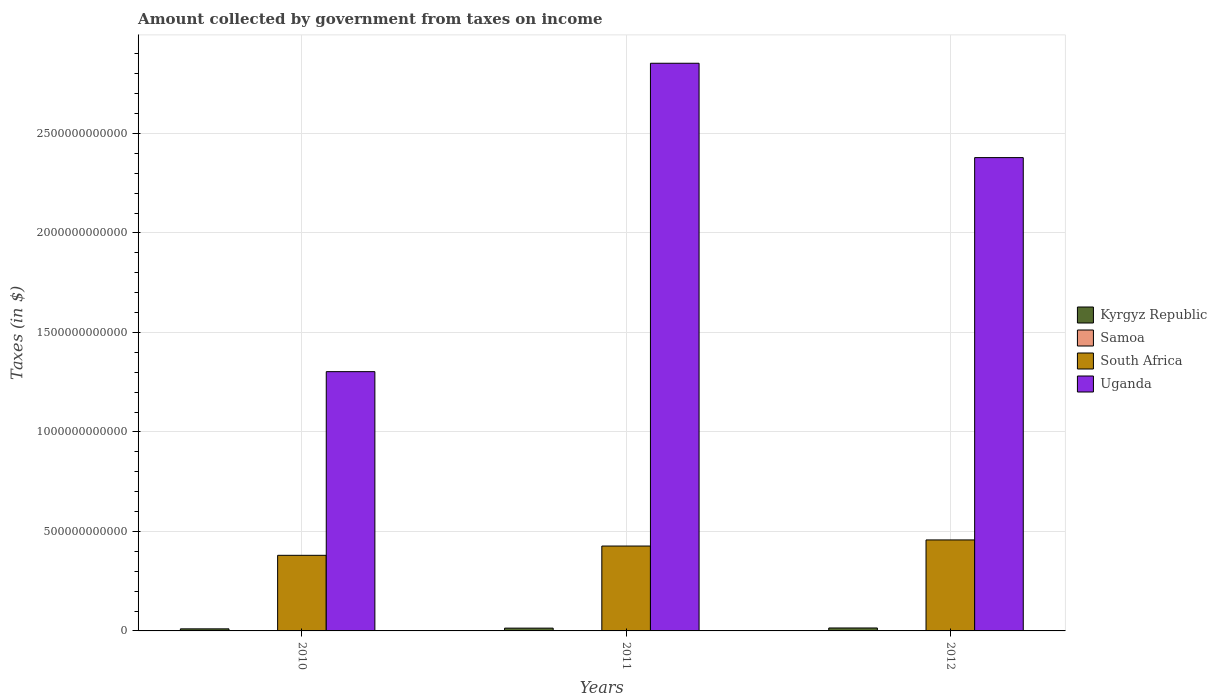Are the number of bars per tick equal to the number of legend labels?
Provide a short and direct response. Yes. How many bars are there on the 1st tick from the left?
Offer a very short reply. 4. What is the amount collected by government from taxes on income in South Africa in 2012?
Keep it short and to the point. 4.57e+11. Across all years, what is the maximum amount collected by government from taxes on income in South Africa?
Make the answer very short. 4.57e+11. Across all years, what is the minimum amount collected by government from taxes on income in South Africa?
Your answer should be very brief. 3.80e+11. In which year was the amount collected by government from taxes on income in Uganda maximum?
Offer a terse response. 2011. What is the total amount collected by government from taxes on income in Samoa in the graph?
Your response must be concise. 2.54e+05. What is the difference between the amount collected by government from taxes on income in Uganda in 2010 and that in 2011?
Make the answer very short. -1.55e+12. What is the difference between the amount collected by government from taxes on income in Uganda in 2011 and the amount collected by government from taxes on income in South Africa in 2012?
Make the answer very short. 2.40e+12. What is the average amount collected by government from taxes on income in Kyrgyz Republic per year?
Provide a short and direct response. 1.31e+1. In the year 2012, what is the difference between the amount collected by government from taxes on income in Samoa and amount collected by government from taxes on income in South Africa?
Keep it short and to the point. -4.57e+11. What is the ratio of the amount collected by government from taxes on income in South Africa in 2010 to that in 2012?
Provide a succinct answer. 0.83. Is the amount collected by government from taxes on income in Kyrgyz Republic in 2011 less than that in 2012?
Your response must be concise. Yes. Is the difference between the amount collected by government from taxes on income in Samoa in 2010 and 2011 greater than the difference between the amount collected by government from taxes on income in South Africa in 2010 and 2011?
Make the answer very short. Yes. What is the difference between the highest and the second highest amount collected by government from taxes on income in Samoa?
Your answer should be very brief. 7012.45. What is the difference between the highest and the lowest amount collected by government from taxes on income in Samoa?
Your answer should be very brief. 1.29e+04. Is the sum of the amount collected by government from taxes on income in Samoa in 2010 and 2011 greater than the maximum amount collected by government from taxes on income in Uganda across all years?
Offer a terse response. No. Is it the case that in every year, the sum of the amount collected by government from taxes on income in South Africa and amount collected by government from taxes on income in Uganda is greater than the sum of amount collected by government from taxes on income in Kyrgyz Republic and amount collected by government from taxes on income in Samoa?
Ensure brevity in your answer.  Yes. What does the 2nd bar from the left in 2011 represents?
Give a very brief answer. Samoa. What does the 2nd bar from the right in 2012 represents?
Offer a very short reply. South Africa. Is it the case that in every year, the sum of the amount collected by government from taxes on income in Uganda and amount collected by government from taxes on income in Kyrgyz Republic is greater than the amount collected by government from taxes on income in South Africa?
Your answer should be compact. Yes. How many bars are there?
Your response must be concise. 12. Are all the bars in the graph horizontal?
Ensure brevity in your answer.  No. What is the difference between two consecutive major ticks on the Y-axis?
Offer a very short reply. 5.00e+11. Are the values on the major ticks of Y-axis written in scientific E-notation?
Offer a terse response. No. Does the graph contain any zero values?
Offer a terse response. No. Where does the legend appear in the graph?
Provide a succinct answer. Center right. How many legend labels are there?
Ensure brevity in your answer.  4. What is the title of the graph?
Offer a very short reply. Amount collected by government from taxes on income. Does "Colombia" appear as one of the legend labels in the graph?
Give a very brief answer. No. What is the label or title of the Y-axis?
Ensure brevity in your answer.  Taxes (in $). What is the Taxes (in $) in Kyrgyz Republic in 2010?
Your response must be concise. 1.04e+1. What is the Taxes (in $) of Samoa in 2010?
Offer a very short reply. 7.85e+04. What is the Taxes (in $) of South Africa in 2010?
Provide a short and direct response. 3.80e+11. What is the Taxes (in $) of Uganda in 2010?
Your response must be concise. 1.30e+12. What is the Taxes (in $) in Kyrgyz Republic in 2011?
Provide a short and direct response. 1.40e+1. What is the Taxes (in $) in Samoa in 2011?
Your response must be concise. 8.44e+04. What is the Taxes (in $) of South Africa in 2011?
Offer a terse response. 4.27e+11. What is the Taxes (in $) of Uganda in 2011?
Your answer should be compact. 2.85e+12. What is the Taxes (in $) of Kyrgyz Republic in 2012?
Your response must be concise. 1.48e+1. What is the Taxes (in $) in Samoa in 2012?
Provide a succinct answer. 9.14e+04. What is the Taxes (in $) in South Africa in 2012?
Offer a very short reply. 4.57e+11. What is the Taxes (in $) in Uganda in 2012?
Your answer should be very brief. 2.38e+12. Across all years, what is the maximum Taxes (in $) in Kyrgyz Republic?
Offer a terse response. 1.48e+1. Across all years, what is the maximum Taxes (in $) of Samoa?
Keep it short and to the point. 9.14e+04. Across all years, what is the maximum Taxes (in $) in South Africa?
Offer a very short reply. 4.57e+11. Across all years, what is the maximum Taxes (in $) in Uganda?
Your answer should be compact. 2.85e+12. Across all years, what is the minimum Taxes (in $) of Kyrgyz Republic?
Offer a very short reply. 1.04e+1. Across all years, what is the minimum Taxes (in $) in Samoa?
Give a very brief answer. 7.85e+04. Across all years, what is the minimum Taxes (in $) in South Africa?
Your answer should be very brief. 3.80e+11. Across all years, what is the minimum Taxes (in $) of Uganda?
Ensure brevity in your answer.  1.30e+12. What is the total Taxes (in $) of Kyrgyz Republic in the graph?
Your answer should be very brief. 3.92e+1. What is the total Taxes (in $) of Samoa in the graph?
Offer a very short reply. 2.54e+05. What is the total Taxes (in $) in South Africa in the graph?
Keep it short and to the point. 1.26e+12. What is the total Taxes (in $) of Uganda in the graph?
Your answer should be compact. 6.53e+12. What is the difference between the Taxes (in $) of Kyrgyz Republic in 2010 and that in 2011?
Ensure brevity in your answer.  -3.59e+09. What is the difference between the Taxes (in $) in Samoa in 2010 and that in 2011?
Ensure brevity in your answer.  -5846.93. What is the difference between the Taxes (in $) in South Africa in 2010 and that in 2011?
Your answer should be very brief. -4.66e+1. What is the difference between the Taxes (in $) in Uganda in 2010 and that in 2011?
Make the answer very short. -1.55e+12. What is the difference between the Taxes (in $) of Kyrgyz Republic in 2010 and that in 2012?
Your response must be concise. -4.42e+09. What is the difference between the Taxes (in $) in Samoa in 2010 and that in 2012?
Your answer should be very brief. -1.29e+04. What is the difference between the Taxes (in $) of South Africa in 2010 and that in 2012?
Make the answer very short. -7.74e+1. What is the difference between the Taxes (in $) of Uganda in 2010 and that in 2012?
Keep it short and to the point. -1.08e+12. What is the difference between the Taxes (in $) of Kyrgyz Republic in 2011 and that in 2012?
Provide a succinct answer. -8.29e+08. What is the difference between the Taxes (in $) of Samoa in 2011 and that in 2012?
Give a very brief answer. -7012.45. What is the difference between the Taxes (in $) in South Africa in 2011 and that in 2012?
Your response must be concise. -3.07e+1. What is the difference between the Taxes (in $) of Uganda in 2011 and that in 2012?
Keep it short and to the point. 4.74e+11. What is the difference between the Taxes (in $) in Kyrgyz Republic in 2010 and the Taxes (in $) in Samoa in 2011?
Offer a terse response. 1.04e+1. What is the difference between the Taxes (in $) of Kyrgyz Republic in 2010 and the Taxes (in $) of South Africa in 2011?
Keep it short and to the point. -4.16e+11. What is the difference between the Taxes (in $) in Kyrgyz Republic in 2010 and the Taxes (in $) in Uganda in 2011?
Your response must be concise. -2.84e+12. What is the difference between the Taxes (in $) in Samoa in 2010 and the Taxes (in $) in South Africa in 2011?
Your answer should be compact. -4.27e+11. What is the difference between the Taxes (in $) of Samoa in 2010 and the Taxes (in $) of Uganda in 2011?
Provide a succinct answer. -2.85e+12. What is the difference between the Taxes (in $) of South Africa in 2010 and the Taxes (in $) of Uganda in 2011?
Offer a terse response. -2.47e+12. What is the difference between the Taxes (in $) of Kyrgyz Republic in 2010 and the Taxes (in $) of Samoa in 2012?
Your answer should be very brief. 1.04e+1. What is the difference between the Taxes (in $) of Kyrgyz Republic in 2010 and the Taxes (in $) of South Africa in 2012?
Your answer should be very brief. -4.47e+11. What is the difference between the Taxes (in $) in Kyrgyz Republic in 2010 and the Taxes (in $) in Uganda in 2012?
Your response must be concise. -2.37e+12. What is the difference between the Taxes (in $) in Samoa in 2010 and the Taxes (in $) in South Africa in 2012?
Provide a short and direct response. -4.57e+11. What is the difference between the Taxes (in $) in Samoa in 2010 and the Taxes (in $) in Uganda in 2012?
Ensure brevity in your answer.  -2.38e+12. What is the difference between the Taxes (in $) in South Africa in 2010 and the Taxes (in $) in Uganda in 2012?
Your response must be concise. -2.00e+12. What is the difference between the Taxes (in $) in Kyrgyz Republic in 2011 and the Taxes (in $) in Samoa in 2012?
Your answer should be very brief. 1.40e+1. What is the difference between the Taxes (in $) in Kyrgyz Republic in 2011 and the Taxes (in $) in South Africa in 2012?
Keep it short and to the point. -4.43e+11. What is the difference between the Taxes (in $) of Kyrgyz Republic in 2011 and the Taxes (in $) of Uganda in 2012?
Make the answer very short. -2.36e+12. What is the difference between the Taxes (in $) in Samoa in 2011 and the Taxes (in $) in South Africa in 2012?
Give a very brief answer. -4.57e+11. What is the difference between the Taxes (in $) of Samoa in 2011 and the Taxes (in $) of Uganda in 2012?
Make the answer very short. -2.38e+12. What is the difference between the Taxes (in $) in South Africa in 2011 and the Taxes (in $) in Uganda in 2012?
Offer a very short reply. -1.95e+12. What is the average Taxes (in $) of Kyrgyz Republic per year?
Give a very brief answer. 1.31e+1. What is the average Taxes (in $) of Samoa per year?
Make the answer very short. 8.48e+04. What is the average Taxes (in $) in South Africa per year?
Keep it short and to the point. 4.21e+11. What is the average Taxes (in $) in Uganda per year?
Your answer should be very brief. 2.18e+12. In the year 2010, what is the difference between the Taxes (in $) of Kyrgyz Republic and Taxes (in $) of Samoa?
Your answer should be very brief. 1.04e+1. In the year 2010, what is the difference between the Taxes (in $) in Kyrgyz Republic and Taxes (in $) in South Africa?
Offer a very short reply. -3.70e+11. In the year 2010, what is the difference between the Taxes (in $) in Kyrgyz Republic and Taxes (in $) in Uganda?
Your answer should be very brief. -1.29e+12. In the year 2010, what is the difference between the Taxes (in $) of Samoa and Taxes (in $) of South Africa?
Give a very brief answer. -3.80e+11. In the year 2010, what is the difference between the Taxes (in $) in Samoa and Taxes (in $) in Uganda?
Your answer should be compact. -1.30e+12. In the year 2010, what is the difference between the Taxes (in $) of South Africa and Taxes (in $) of Uganda?
Ensure brevity in your answer.  -9.23e+11. In the year 2011, what is the difference between the Taxes (in $) in Kyrgyz Republic and Taxes (in $) in Samoa?
Keep it short and to the point. 1.40e+1. In the year 2011, what is the difference between the Taxes (in $) of Kyrgyz Republic and Taxes (in $) of South Africa?
Your response must be concise. -4.13e+11. In the year 2011, what is the difference between the Taxes (in $) in Kyrgyz Republic and Taxes (in $) in Uganda?
Provide a succinct answer. -2.84e+12. In the year 2011, what is the difference between the Taxes (in $) of Samoa and Taxes (in $) of South Africa?
Your response must be concise. -4.27e+11. In the year 2011, what is the difference between the Taxes (in $) of Samoa and Taxes (in $) of Uganda?
Make the answer very short. -2.85e+12. In the year 2011, what is the difference between the Taxes (in $) of South Africa and Taxes (in $) of Uganda?
Provide a succinct answer. -2.43e+12. In the year 2012, what is the difference between the Taxes (in $) in Kyrgyz Republic and Taxes (in $) in Samoa?
Your answer should be very brief. 1.48e+1. In the year 2012, what is the difference between the Taxes (in $) in Kyrgyz Republic and Taxes (in $) in South Africa?
Offer a terse response. -4.43e+11. In the year 2012, what is the difference between the Taxes (in $) of Kyrgyz Republic and Taxes (in $) of Uganda?
Provide a short and direct response. -2.36e+12. In the year 2012, what is the difference between the Taxes (in $) in Samoa and Taxes (in $) in South Africa?
Ensure brevity in your answer.  -4.57e+11. In the year 2012, what is the difference between the Taxes (in $) in Samoa and Taxes (in $) in Uganda?
Your answer should be very brief. -2.38e+12. In the year 2012, what is the difference between the Taxes (in $) in South Africa and Taxes (in $) in Uganda?
Give a very brief answer. -1.92e+12. What is the ratio of the Taxes (in $) of Kyrgyz Republic in 2010 to that in 2011?
Offer a terse response. 0.74. What is the ratio of the Taxes (in $) of Samoa in 2010 to that in 2011?
Provide a short and direct response. 0.93. What is the ratio of the Taxes (in $) of South Africa in 2010 to that in 2011?
Ensure brevity in your answer.  0.89. What is the ratio of the Taxes (in $) of Uganda in 2010 to that in 2011?
Your response must be concise. 0.46. What is the ratio of the Taxes (in $) of Kyrgyz Republic in 2010 to that in 2012?
Offer a very short reply. 0.7. What is the ratio of the Taxes (in $) in Samoa in 2010 to that in 2012?
Make the answer very short. 0.86. What is the ratio of the Taxes (in $) in South Africa in 2010 to that in 2012?
Provide a short and direct response. 0.83. What is the ratio of the Taxes (in $) of Uganda in 2010 to that in 2012?
Your answer should be very brief. 0.55. What is the ratio of the Taxes (in $) in Kyrgyz Republic in 2011 to that in 2012?
Offer a very short reply. 0.94. What is the ratio of the Taxes (in $) in Samoa in 2011 to that in 2012?
Your answer should be compact. 0.92. What is the ratio of the Taxes (in $) in South Africa in 2011 to that in 2012?
Ensure brevity in your answer.  0.93. What is the ratio of the Taxes (in $) in Uganda in 2011 to that in 2012?
Offer a very short reply. 1.2. What is the difference between the highest and the second highest Taxes (in $) in Kyrgyz Republic?
Offer a terse response. 8.29e+08. What is the difference between the highest and the second highest Taxes (in $) in Samoa?
Your answer should be compact. 7012.45. What is the difference between the highest and the second highest Taxes (in $) in South Africa?
Give a very brief answer. 3.07e+1. What is the difference between the highest and the second highest Taxes (in $) in Uganda?
Make the answer very short. 4.74e+11. What is the difference between the highest and the lowest Taxes (in $) in Kyrgyz Republic?
Provide a succinct answer. 4.42e+09. What is the difference between the highest and the lowest Taxes (in $) in Samoa?
Your answer should be compact. 1.29e+04. What is the difference between the highest and the lowest Taxes (in $) in South Africa?
Your response must be concise. 7.74e+1. What is the difference between the highest and the lowest Taxes (in $) of Uganda?
Your response must be concise. 1.55e+12. 